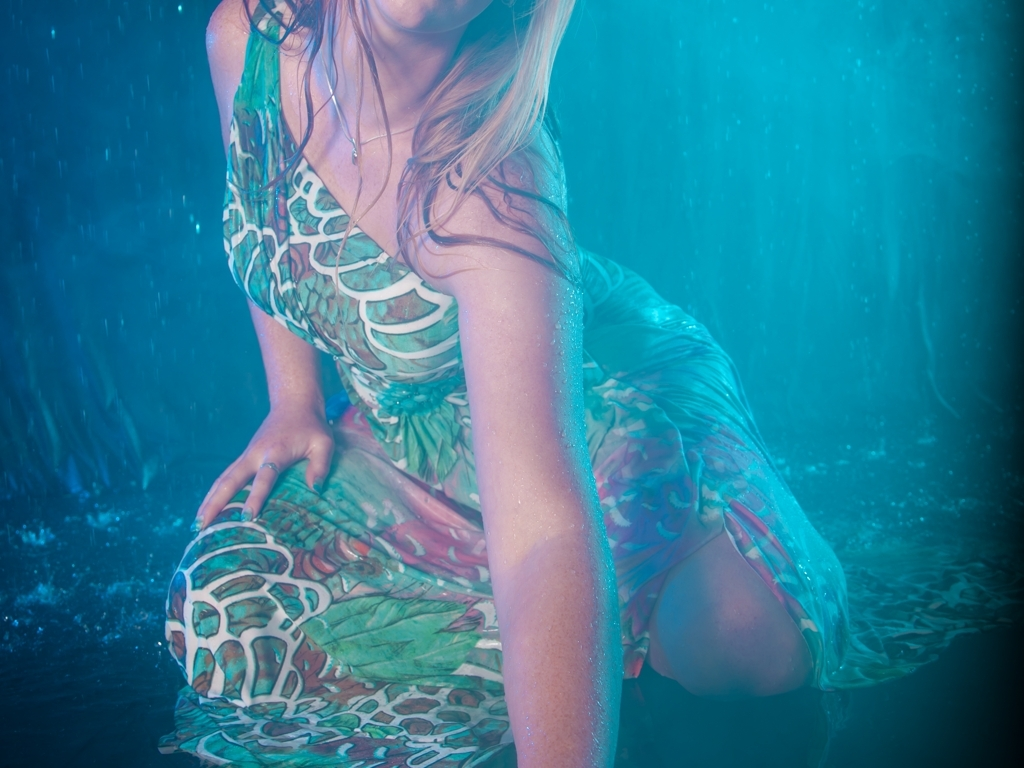Are the details of the person's hair, skin, and clothing texture clear?
A. No
B. Yes
Answer with the option's letter from the given choices directly.
 B. 